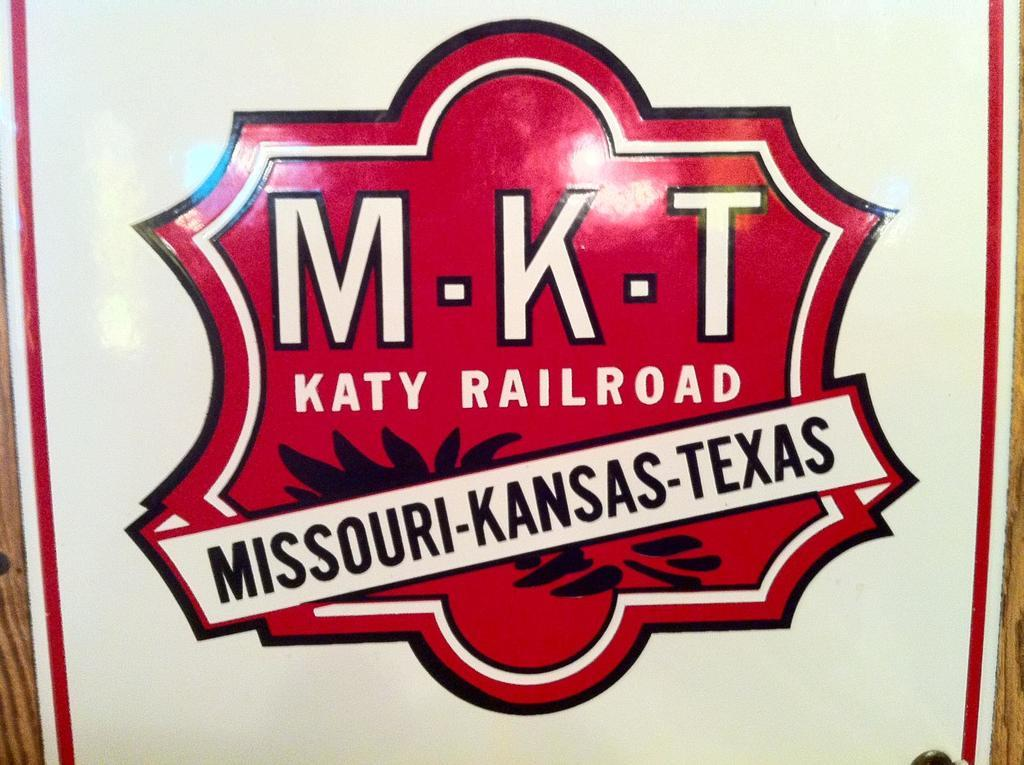Provide a one-sentence caption for the provided image. The states listed are Missouri-Kansas-Texas on the poster. 